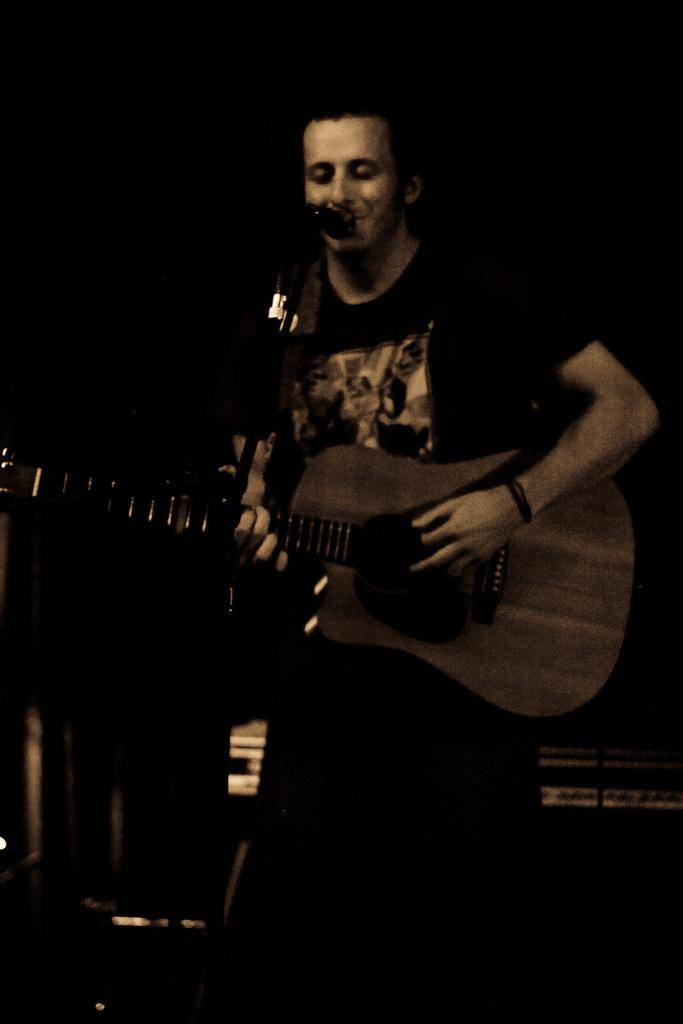What is the man in the image doing? The man is singing and playing a guitar. What instrument is the man playing in the image? The man is playing a guitar. What type of tray is the man using to sing in the image? There is no tray present in the image, and the man is not using any tray to sing. 